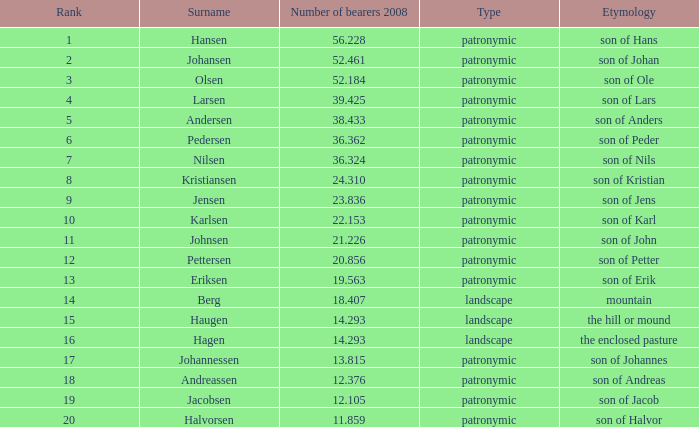What is the category, when count of bearers 2008 exceeds 1 Patronymic. 